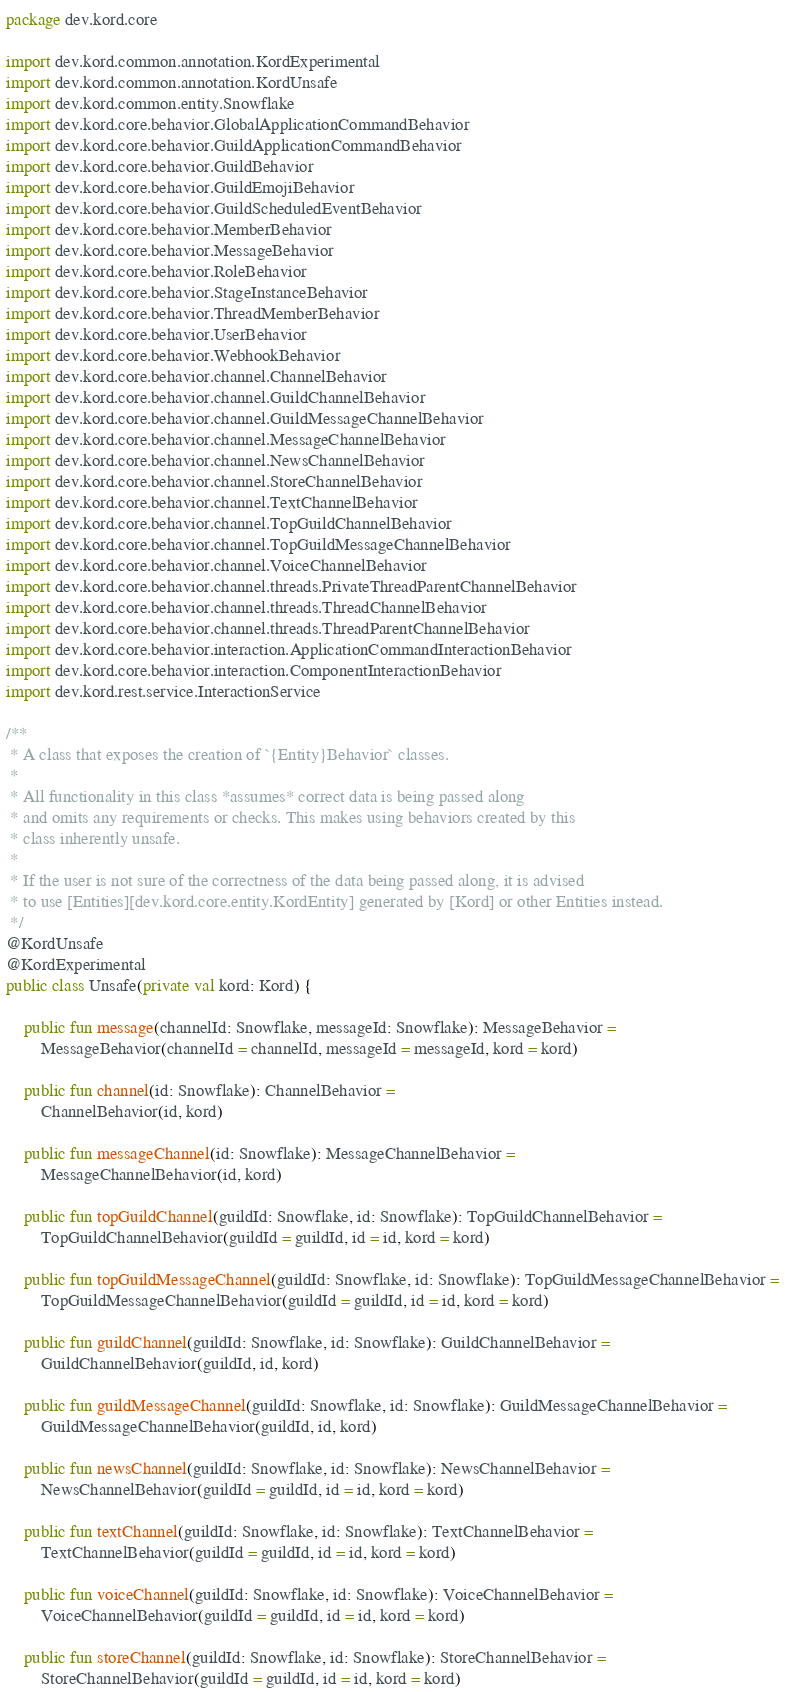<code> <loc_0><loc_0><loc_500><loc_500><_Kotlin_>package dev.kord.core

import dev.kord.common.annotation.KordExperimental
import dev.kord.common.annotation.KordUnsafe
import dev.kord.common.entity.Snowflake
import dev.kord.core.behavior.GlobalApplicationCommandBehavior
import dev.kord.core.behavior.GuildApplicationCommandBehavior
import dev.kord.core.behavior.GuildBehavior
import dev.kord.core.behavior.GuildEmojiBehavior
import dev.kord.core.behavior.GuildScheduledEventBehavior
import dev.kord.core.behavior.MemberBehavior
import dev.kord.core.behavior.MessageBehavior
import dev.kord.core.behavior.RoleBehavior
import dev.kord.core.behavior.StageInstanceBehavior
import dev.kord.core.behavior.ThreadMemberBehavior
import dev.kord.core.behavior.UserBehavior
import dev.kord.core.behavior.WebhookBehavior
import dev.kord.core.behavior.channel.ChannelBehavior
import dev.kord.core.behavior.channel.GuildChannelBehavior
import dev.kord.core.behavior.channel.GuildMessageChannelBehavior
import dev.kord.core.behavior.channel.MessageChannelBehavior
import dev.kord.core.behavior.channel.NewsChannelBehavior
import dev.kord.core.behavior.channel.StoreChannelBehavior
import dev.kord.core.behavior.channel.TextChannelBehavior
import dev.kord.core.behavior.channel.TopGuildChannelBehavior
import dev.kord.core.behavior.channel.TopGuildMessageChannelBehavior
import dev.kord.core.behavior.channel.VoiceChannelBehavior
import dev.kord.core.behavior.channel.threads.PrivateThreadParentChannelBehavior
import dev.kord.core.behavior.channel.threads.ThreadChannelBehavior
import dev.kord.core.behavior.channel.threads.ThreadParentChannelBehavior
import dev.kord.core.behavior.interaction.ApplicationCommandInteractionBehavior
import dev.kord.core.behavior.interaction.ComponentInteractionBehavior
import dev.kord.rest.service.InteractionService

/**
 * A class that exposes the creation of `{Entity}Behavior` classes.
 *
 * All functionality in this class *assumes* correct data is being passed along
 * and omits any requirements or checks. This makes using behaviors created by this
 * class inherently unsafe.
 *
 * If the user is not sure of the correctness of the data being passed along, it is advised
 * to use [Entities][dev.kord.core.entity.KordEntity] generated by [Kord] or other Entities instead.
 */
@KordUnsafe
@KordExperimental
public class Unsafe(private val kord: Kord) {

    public fun message(channelId: Snowflake, messageId: Snowflake): MessageBehavior =
        MessageBehavior(channelId = channelId, messageId = messageId, kord = kord)

    public fun channel(id: Snowflake): ChannelBehavior =
        ChannelBehavior(id, kord)

    public fun messageChannel(id: Snowflake): MessageChannelBehavior =
        MessageChannelBehavior(id, kord)

    public fun topGuildChannel(guildId: Snowflake, id: Snowflake): TopGuildChannelBehavior =
        TopGuildChannelBehavior(guildId = guildId, id = id, kord = kord)

    public fun topGuildMessageChannel(guildId: Snowflake, id: Snowflake): TopGuildMessageChannelBehavior =
        TopGuildMessageChannelBehavior(guildId = guildId, id = id, kord = kord)

    public fun guildChannel(guildId: Snowflake, id: Snowflake): GuildChannelBehavior =
        GuildChannelBehavior(guildId, id, kord)

    public fun guildMessageChannel(guildId: Snowflake, id: Snowflake): GuildMessageChannelBehavior =
        GuildMessageChannelBehavior(guildId, id, kord)

    public fun newsChannel(guildId: Snowflake, id: Snowflake): NewsChannelBehavior =
        NewsChannelBehavior(guildId = guildId, id = id, kord = kord)

    public fun textChannel(guildId: Snowflake, id: Snowflake): TextChannelBehavior =
        TextChannelBehavior(guildId = guildId, id = id, kord = kord)

    public fun voiceChannel(guildId: Snowflake, id: Snowflake): VoiceChannelBehavior =
        VoiceChannelBehavior(guildId = guildId, id = id, kord = kord)

    public fun storeChannel(guildId: Snowflake, id: Snowflake): StoreChannelBehavior =
        StoreChannelBehavior(guildId = guildId, id = id, kord = kord)
</code> 